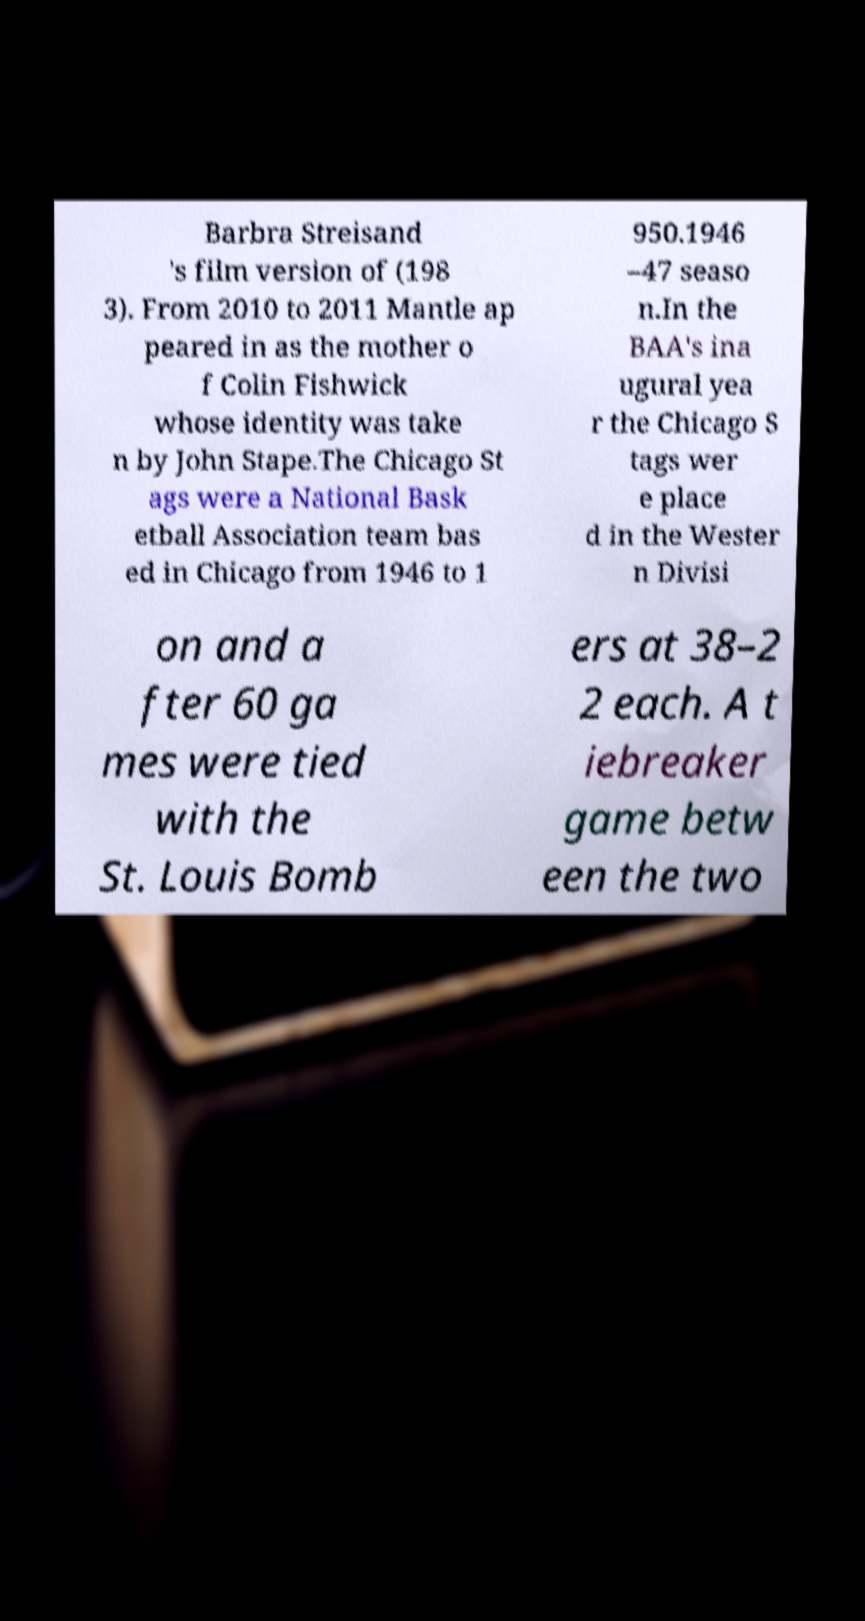Please identify and transcribe the text found in this image. Barbra Streisand 's film version of (198 3). From 2010 to 2011 Mantle ap peared in as the mother o f Colin Fishwick whose identity was take n by John Stape.The Chicago St ags were a National Bask etball Association team bas ed in Chicago from 1946 to 1 950.1946 –47 seaso n.In the BAA's ina ugural yea r the Chicago S tags wer e place d in the Wester n Divisi on and a fter 60 ga mes were tied with the St. Louis Bomb ers at 38–2 2 each. A t iebreaker game betw een the two 